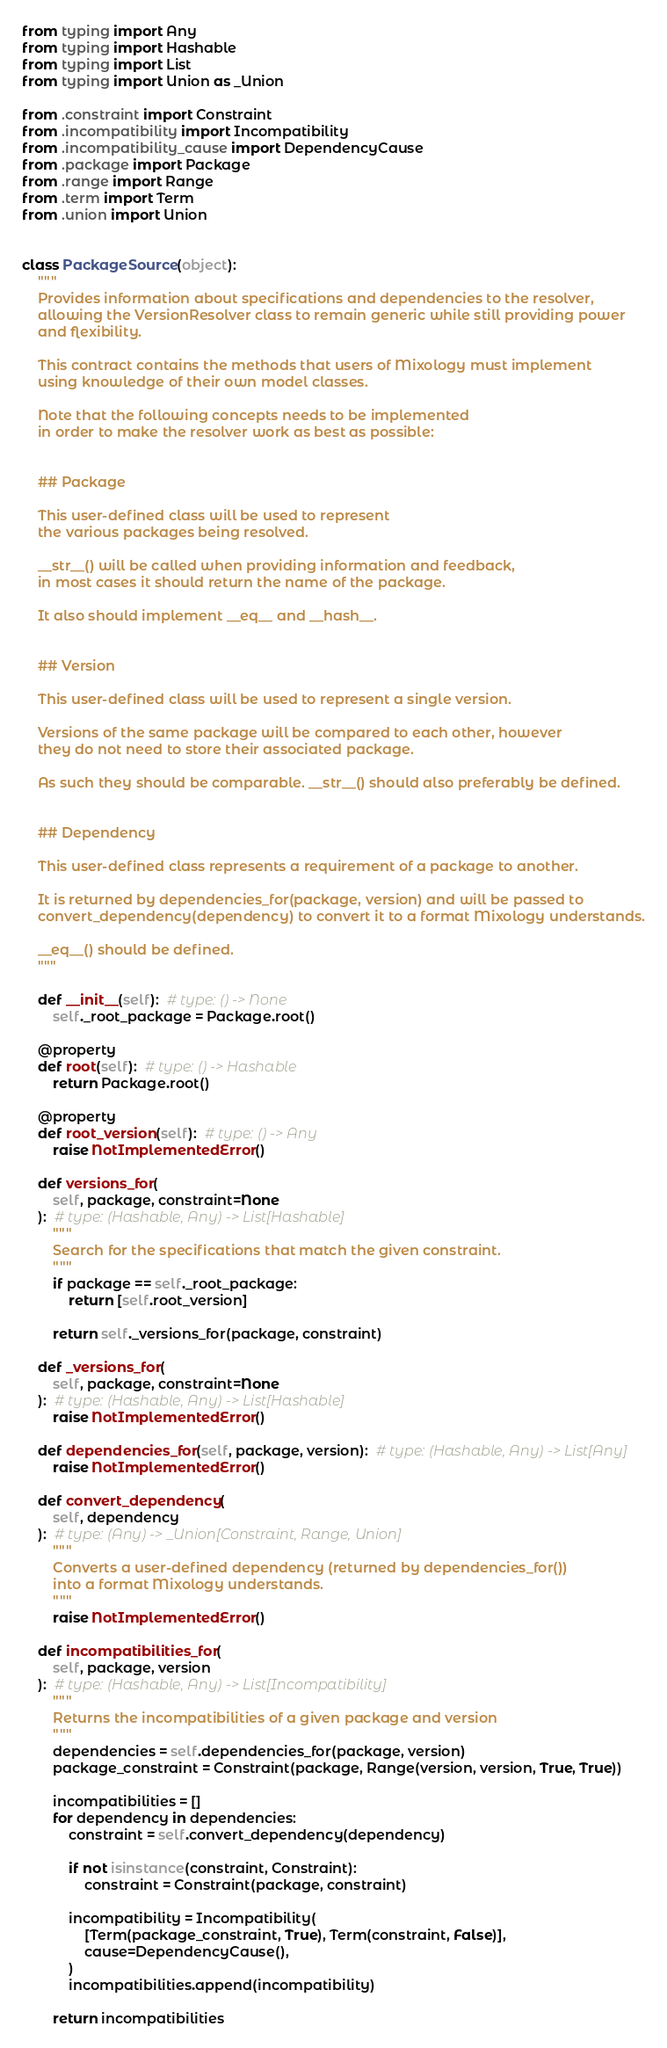Convert code to text. <code><loc_0><loc_0><loc_500><loc_500><_Python_>from typing import Any
from typing import Hashable
from typing import List
from typing import Union as _Union

from .constraint import Constraint
from .incompatibility import Incompatibility
from .incompatibility_cause import DependencyCause
from .package import Package
from .range import Range
from .term import Term
from .union import Union


class PackageSource(object):
    """
    Provides information about specifications and dependencies to the resolver,
    allowing the VersionResolver class to remain generic while still providing power
    and flexibility.

    This contract contains the methods that users of Mixology must implement
    using knowledge of their own model classes.

    Note that the following concepts needs to be implemented
    in order to make the resolver work as best as possible:


    ## Package

    This user-defined class will be used to represent
    the various packages being resolved.

    __str__() will be called when providing information and feedback,
    in most cases it should return the name of the package.

    It also should implement __eq__ and __hash__.


    ## Version

    This user-defined class will be used to represent a single version.

    Versions of the same package will be compared to each other, however
    they do not need to store their associated package.

    As such they should be comparable. __str__() should also preferably be defined.


    ## Dependency

    This user-defined class represents a requirement of a package to another.

    It is returned by dependencies_for(package, version) and will be passed to
    convert_dependency(dependency) to convert it to a format Mixology understands.

    __eq__() should be defined.
    """

    def __init__(self):  # type: () -> None
        self._root_package = Package.root()

    @property
    def root(self):  # type: () -> Hashable
        return Package.root()

    @property
    def root_version(self):  # type: () -> Any
        raise NotImplementedError()

    def versions_for(
        self, package, constraint=None
    ):  # type: (Hashable, Any) -> List[Hashable]
        """
        Search for the specifications that match the given constraint.
        """
        if package == self._root_package:
            return [self.root_version]

        return self._versions_for(package, constraint)

    def _versions_for(
        self, package, constraint=None
    ):  # type: (Hashable, Any) -> List[Hashable]
        raise NotImplementedError()

    def dependencies_for(self, package, version):  # type: (Hashable, Any) -> List[Any]
        raise NotImplementedError()

    def convert_dependency(
        self, dependency
    ):  # type: (Any) -> _Union[Constraint, Range, Union]
        """
        Converts a user-defined dependency (returned by dependencies_for())
        into a format Mixology understands.
        """
        raise NotImplementedError()

    def incompatibilities_for(
        self, package, version
    ):  # type: (Hashable, Any) -> List[Incompatibility]
        """
        Returns the incompatibilities of a given package and version
        """
        dependencies = self.dependencies_for(package, version)
        package_constraint = Constraint(package, Range(version, version, True, True))

        incompatibilities = []
        for dependency in dependencies:
            constraint = self.convert_dependency(dependency)

            if not isinstance(constraint, Constraint):
                constraint = Constraint(package, constraint)

            incompatibility = Incompatibility(
                [Term(package_constraint, True), Term(constraint, False)],
                cause=DependencyCause(),
            )
            incompatibilities.append(incompatibility)

        return incompatibilities
</code> 